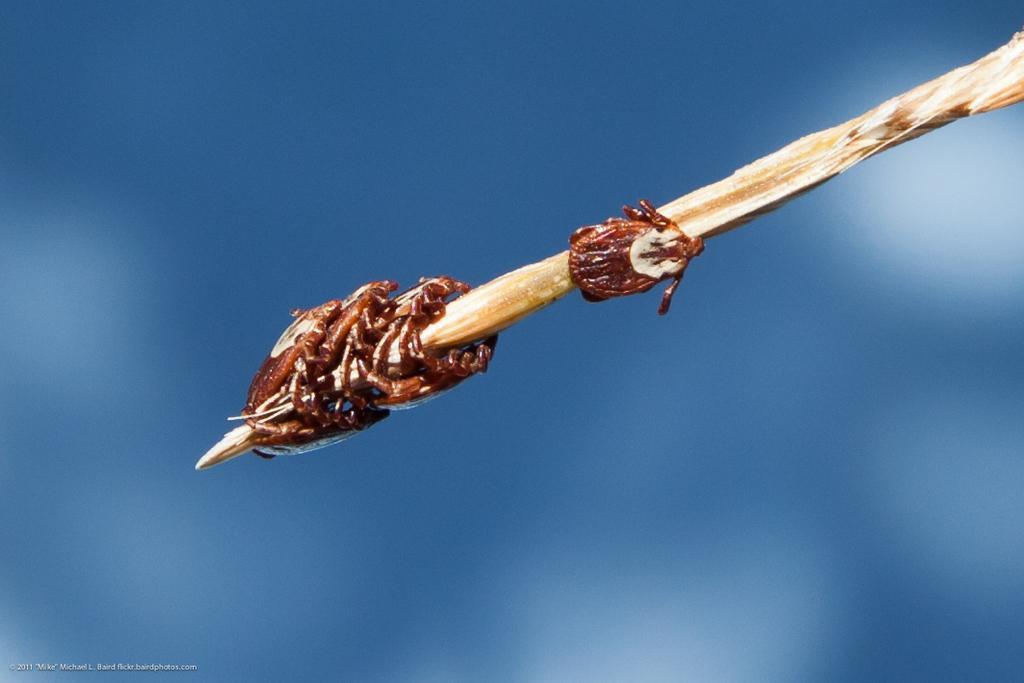How would you summarize this image in a sentence or two? In this image there is a stick on which there are small insects. 